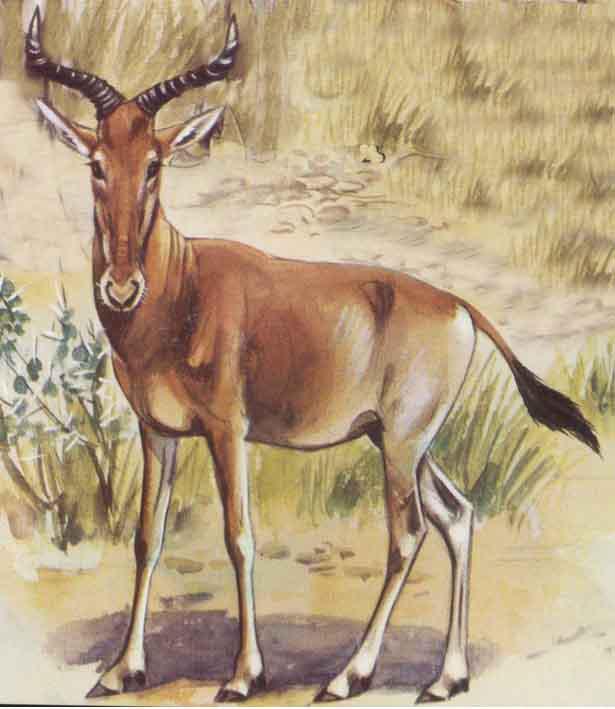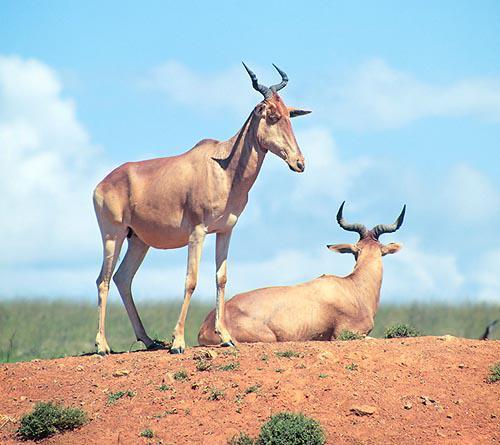The first image is the image on the left, the second image is the image on the right. Examine the images to the left and right. Is the description "The image on the right contains a horned mammal looking to the right." accurate? Answer yes or no. Yes. The first image is the image on the left, the second image is the image on the right. Examine the images to the left and right. Is the description "Each image contains just one horned animal, and the animals in the right and left images face away from each other." accurate? Answer yes or no. No. 